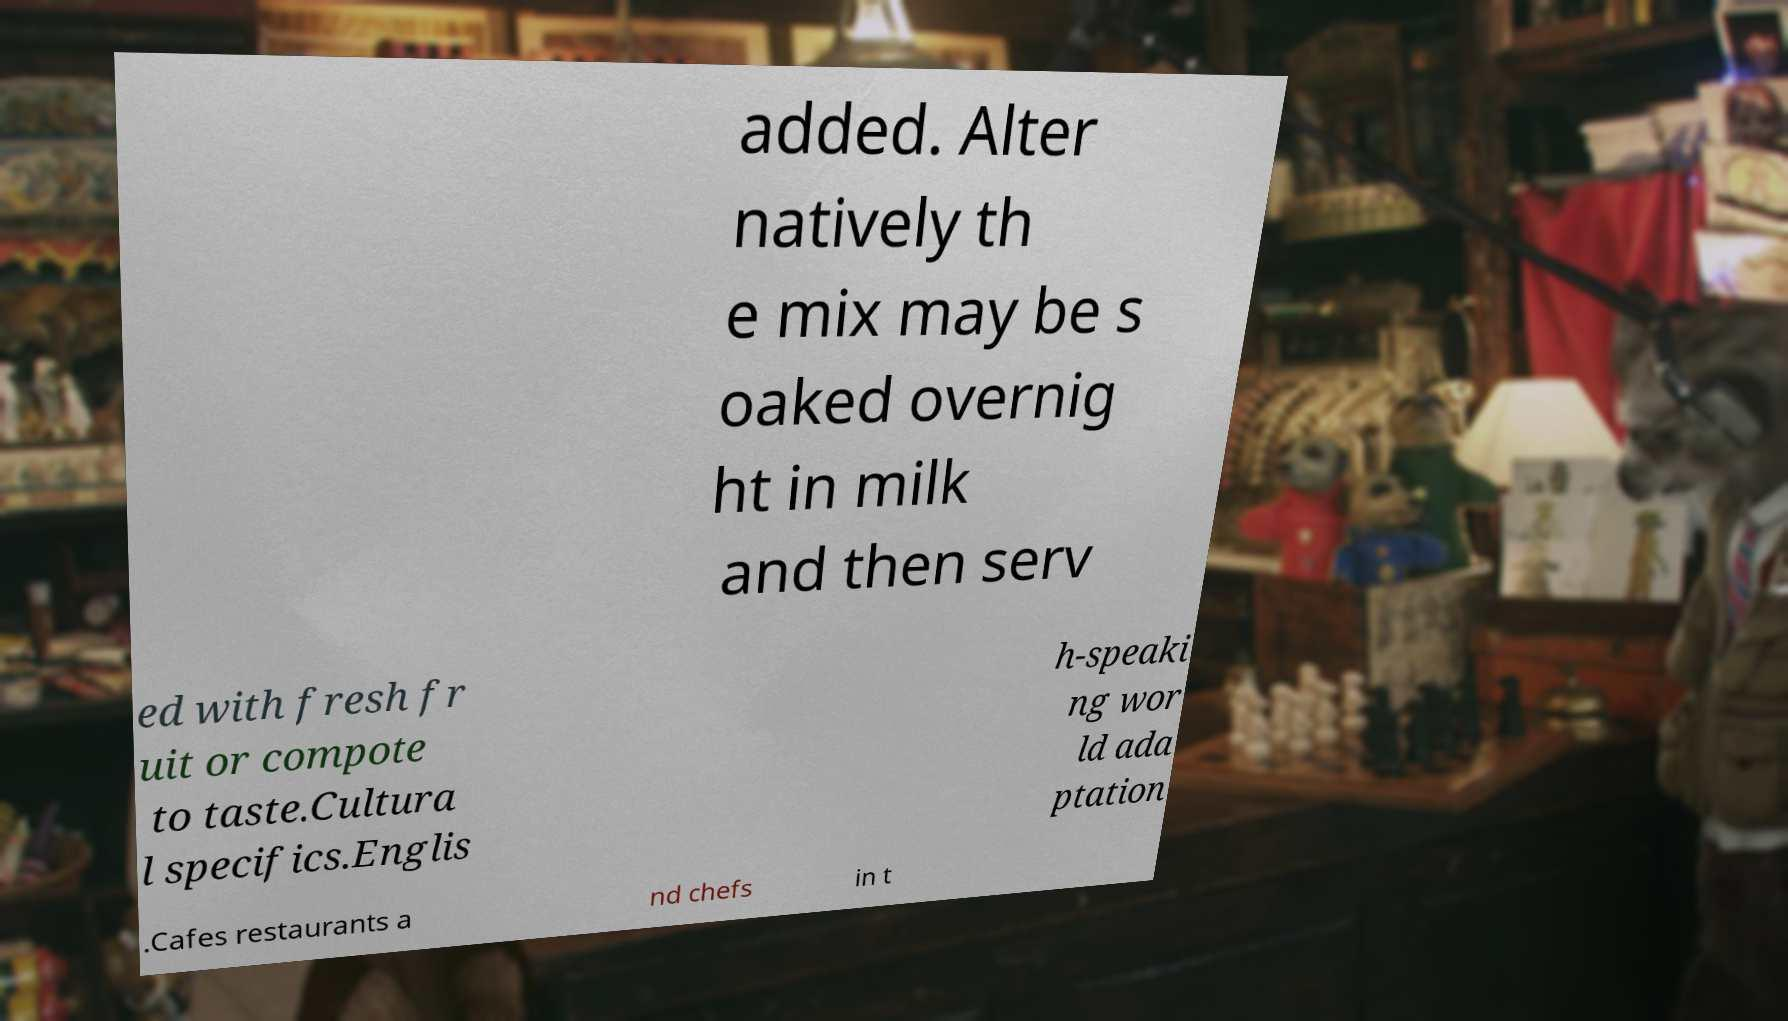What messages or text are displayed in this image? I need them in a readable, typed format. added. Alter natively th e mix may be s oaked overnig ht in milk and then serv ed with fresh fr uit or compote to taste.Cultura l specifics.Englis h-speaki ng wor ld ada ptation .Cafes restaurants a nd chefs in t 